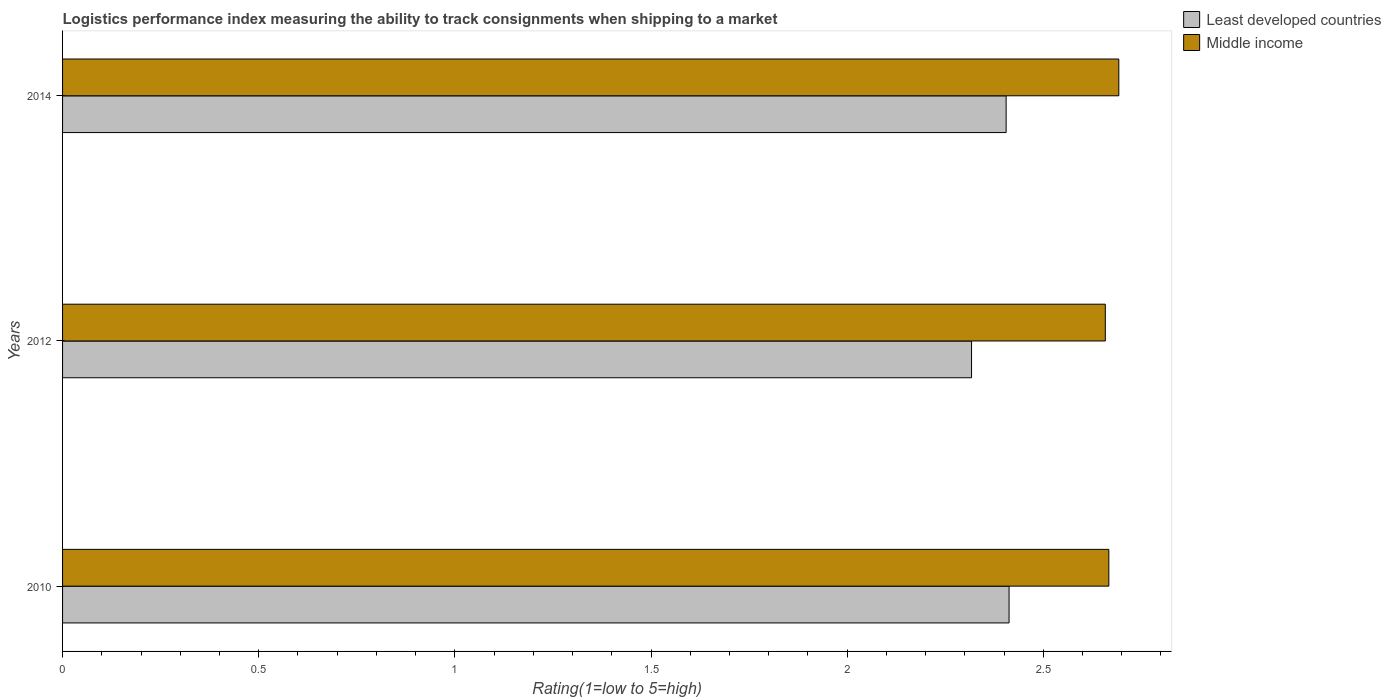Are the number of bars per tick equal to the number of legend labels?
Ensure brevity in your answer.  Yes. Are the number of bars on each tick of the Y-axis equal?
Provide a short and direct response. Yes. How many bars are there on the 2nd tick from the top?
Provide a short and direct response. 2. What is the Logistic performance index in Least developed countries in 2012?
Provide a succinct answer. 2.32. Across all years, what is the maximum Logistic performance index in Middle income?
Your response must be concise. 2.69. Across all years, what is the minimum Logistic performance index in Middle income?
Give a very brief answer. 2.66. What is the total Logistic performance index in Middle income in the graph?
Make the answer very short. 8.02. What is the difference between the Logistic performance index in Least developed countries in 2010 and that in 2012?
Give a very brief answer. 0.1. What is the difference between the Logistic performance index in Middle income in 2014 and the Logistic performance index in Least developed countries in 2012?
Make the answer very short. 0.38. What is the average Logistic performance index in Middle income per year?
Your answer should be very brief. 2.67. In the year 2010, what is the difference between the Logistic performance index in Middle income and Logistic performance index in Least developed countries?
Provide a short and direct response. 0.25. What is the ratio of the Logistic performance index in Middle income in 2010 to that in 2012?
Provide a short and direct response. 1. Is the Logistic performance index in Middle income in 2010 less than that in 2014?
Your response must be concise. Yes. Is the difference between the Logistic performance index in Middle income in 2010 and 2014 greater than the difference between the Logistic performance index in Least developed countries in 2010 and 2014?
Your response must be concise. No. What is the difference between the highest and the second highest Logistic performance index in Least developed countries?
Your answer should be compact. 0.01. What is the difference between the highest and the lowest Logistic performance index in Middle income?
Keep it short and to the point. 0.03. What does the 2nd bar from the top in 2014 represents?
Keep it short and to the point. Least developed countries. What does the 2nd bar from the bottom in 2014 represents?
Your response must be concise. Middle income. Are all the bars in the graph horizontal?
Make the answer very short. Yes. How many years are there in the graph?
Give a very brief answer. 3. Are the values on the major ticks of X-axis written in scientific E-notation?
Offer a terse response. No. Where does the legend appear in the graph?
Offer a terse response. Top right. How many legend labels are there?
Offer a terse response. 2. How are the legend labels stacked?
Provide a short and direct response. Vertical. What is the title of the graph?
Give a very brief answer. Logistics performance index measuring the ability to track consignments when shipping to a market. Does "East Asia (all income levels)" appear as one of the legend labels in the graph?
Your response must be concise. No. What is the label or title of the X-axis?
Your answer should be very brief. Rating(1=low to 5=high). What is the Rating(1=low to 5=high) of Least developed countries in 2010?
Provide a succinct answer. 2.41. What is the Rating(1=low to 5=high) of Middle income in 2010?
Provide a short and direct response. 2.67. What is the Rating(1=low to 5=high) of Least developed countries in 2012?
Provide a short and direct response. 2.32. What is the Rating(1=low to 5=high) in Middle income in 2012?
Your response must be concise. 2.66. What is the Rating(1=low to 5=high) in Least developed countries in 2014?
Provide a succinct answer. 2.41. What is the Rating(1=low to 5=high) of Middle income in 2014?
Provide a short and direct response. 2.69. Across all years, what is the maximum Rating(1=low to 5=high) in Least developed countries?
Your answer should be compact. 2.41. Across all years, what is the maximum Rating(1=low to 5=high) in Middle income?
Ensure brevity in your answer.  2.69. Across all years, what is the minimum Rating(1=low to 5=high) in Least developed countries?
Provide a succinct answer. 2.32. Across all years, what is the minimum Rating(1=low to 5=high) of Middle income?
Provide a succinct answer. 2.66. What is the total Rating(1=low to 5=high) in Least developed countries in the graph?
Your answer should be compact. 7.14. What is the total Rating(1=low to 5=high) of Middle income in the graph?
Your response must be concise. 8.02. What is the difference between the Rating(1=low to 5=high) of Least developed countries in 2010 and that in 2012?
Give a very brief answer. 0.1. What is the difference between the Rating(1=low to 5=high) of Middle income in 2010 and that in 2012?
Offer a very short reply. 0.01. What is the difference between the Rating(1=low to 5=high) of Least developed countries in 2010 and that in 2014?
Provide a succinct answer. 0.01. What is the difference between the Rating(1=low to 5=high) in Middle income in 2010 and that in 2014?
Keep it short and to the point. -0.03. What is the difference between the Rating(1=low to 5=high) in Least developed countries in 2012 and that in 2014?
Provide a short and direct response. -0.09. What is the difference between the Rating(1=low to 5=high) in Middle income in 2012 and that in 2014?
Your response must be concise. -0.03. What is the difference between the Rating(1=low to 5=high) of Least developed countries in 2010 and the Rating(1=low to 5=high) of Middle income in 2012?
Your answer should be compact. -0.25. What is the difference between the Rating(1=low to 5=high) in Least developed countries in 2010 and the Rating(1=low to 5=high) in Middle income in 2014?
Provide a succinct answer. -0.28. What is the difference between the Rating(1=low to 5=high) in Least developed countries in 2012 and the Rating(1=low to 5=high) in Middle income in 2014?
Offer a terse response. -0.38. What is the average Rating(1=low to 5=high) of Least developed countries per year?
Your answer should be compact. 2.38. What is the average Rating(1=low to 5=high) in Middle income per year?
Provide a succinct answer. 2.67. In the year 2010, what is the difference between the Rating(1=low to 5=high) of Least developed countries and Rating(1=low to 5=high) of Middle income?
Provide a succinct answer. -0.25. In the year 2012, what is the difference between the Rating(1=low to 5=high) in Least developed countries and Rating(1=low to 5=high) in Middle income?
Your response must be concise. -0.34. In the year 2014, what is the difference between the Rating(1=low to 5=high) of Least developed countries and Rating(1=low to 5=high) of Middle income?
Ensure brevity in your answer.  -0.29. What is the ratio of the Rating(1=low to 5=high) in Least developed countries in 2010 to that in 2012?
Offer a very short reply. 1.04. What is the ratio of the Rating(1=low to 5=high) in Middle income in 2010 to that in 2014?
Your response must be concise. 0.99. What is the ratio of the Rating(1=low to 5=high) of Least developed countries in 2012 to that in 2014?
Offer a very short reply. 0.96. What is the ratio of the Rating(1=low to 5=high) in Middle income in 2012 to that in 2014?
Your answer should be compact. 0.99. What is the difference between the highest and the second highest Rating(1=low to 5=high) of Least developed countries?
Your response must be concise. 0.01. What is the difference between the highest and the second highest Rating(1=low to 5=high) of Middle income?
Provide a short and direct response. 0.03. What is the difference between the highest and the lowest Rating(1=low to 5=high) of Least developed countries?
Offer a very short reply. 0.1. What is the difference between the highest and the lowest Rating(1=low to 5=high) in Middle income?
Your response must be concise. 0.03. 